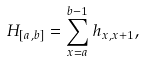<formula> <loc_0><loc_0><loc_500><loc_500>H _ { [ a , b ] } = \sum _ { x = a } ^ { b - 1 } h _ { x , x + 1 } ,</formula> 